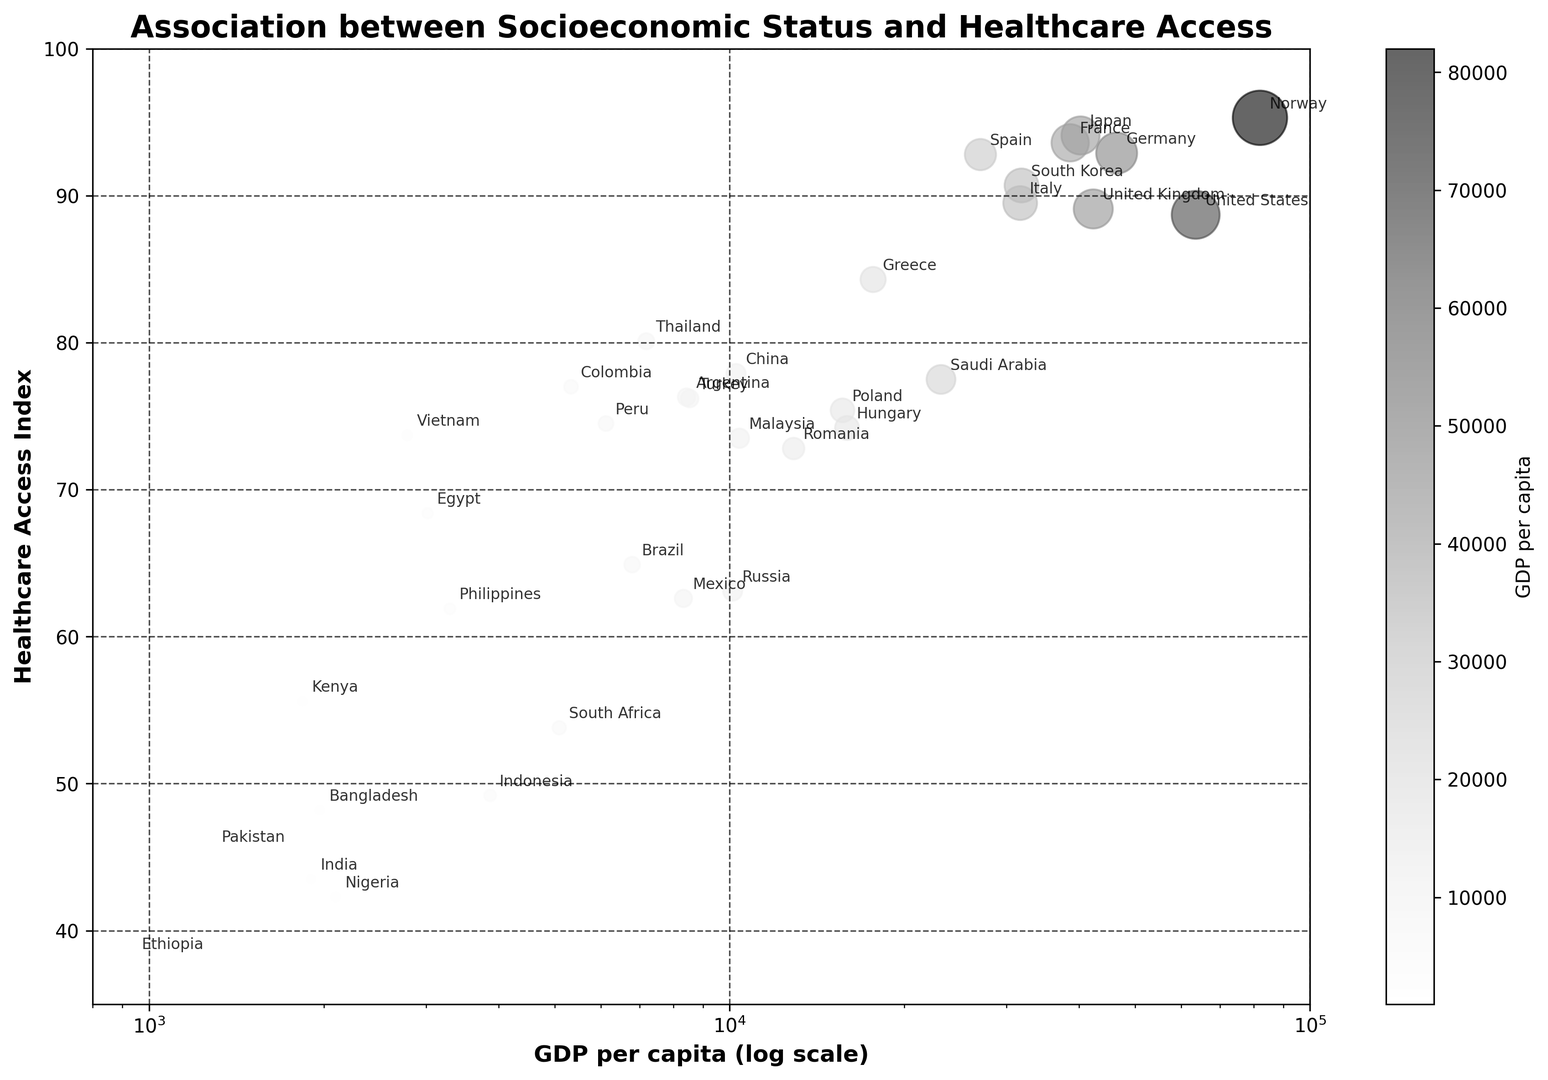What is the relationship between GDP per capita and the Healthcare Access Index? In the scatter plot, countries with higher GDP per capita generally appear to have a higher Healthcare Access Index. For example, Norway and Japan with high GDPs have high Healthcare Access Index values. Meanwhile, countries with lower GDP, such as Ethiopia and India, show lower Healthcare Access Index values.
Answer: Positive correlation Which country has the highest Healthcare Access Index and what is its GDP per capita? By examining the scatter plot, Norway is labeled with the highest Healthcare Access Index of 95.3. Norway's GDP per capita is 81995.
Answer: Norway, 81995 Identify any outliers in terms of healthcare access compared to their GDP per capita. Saudi Arabia stands out as an outlier. Despite having a relatively high GDP per capita (23139), it has a lower Healthcare Access Index (77.5) compared to other countries with similar GDP.
Answer: Saudi Arabia Which countries are closest to the median Healthcare Access Index value? By looking at the vertical distribution, the median of the Healthcare Access Index (around 76) corresponds to countries like Turkey (76.2), Argentina (76.3), and Colombia (77.0).
Answer: Turkey, Argentina, Colombia Which country has the lowest GDP per capita and what is its Healthcare Access Index? The scatter plot shows that Ethiopia has the lowest GDP per capita (936). Its Healthcare Access Index is 38.1.
Answer: Ethiopia, 38.1 How does the Healthcare Access Index of the United States compare to that of Japan? The scatter plot indicates that the United States has a Healthcare Access Index of 88.7, while Japan has a higher index at 94.1.
Answer: Japan has a higher index than the United States Between Poland and Hungary, which country has a higher Healthcare Access Index and by how much? Poland's Healthcare Access Index is 75.4 while Hungary's is 74.2. By calculating the difference: 75.4 - 74.2 = 1.2
Answer: Poland by 1.2 Which countries have a Healthcare Access Index below 50, and what are their GDP per capita values? From the scatter plot, countries with a Healthcare Access Index below 50 are India (43.5), Nigeria (42.3), Ethiopia (38.1), Indonesia (49.2), and Pakistan (45.4). Their GDPs are 1901, 2097, 936, 3870, and 1284 respectively.
Answer: India, Nigeria, Ethiopia, Indonesia, Pakistan What is the average Healthcare Access Index of countries with GDP per capita over 40,000? From the scatter plot, countries with GDP per capita over 40,000 are Norway, United States, Germany, United Kingdom, and Japan. Their index values are 95.3, 88.7, 92.9, 89.1, and 94.1 respectively. The average is calculated as (95.3 + 88.7 + 92.9 + 89.1 + 94.1) / 5 = 92.02.
Answer: 92.02 